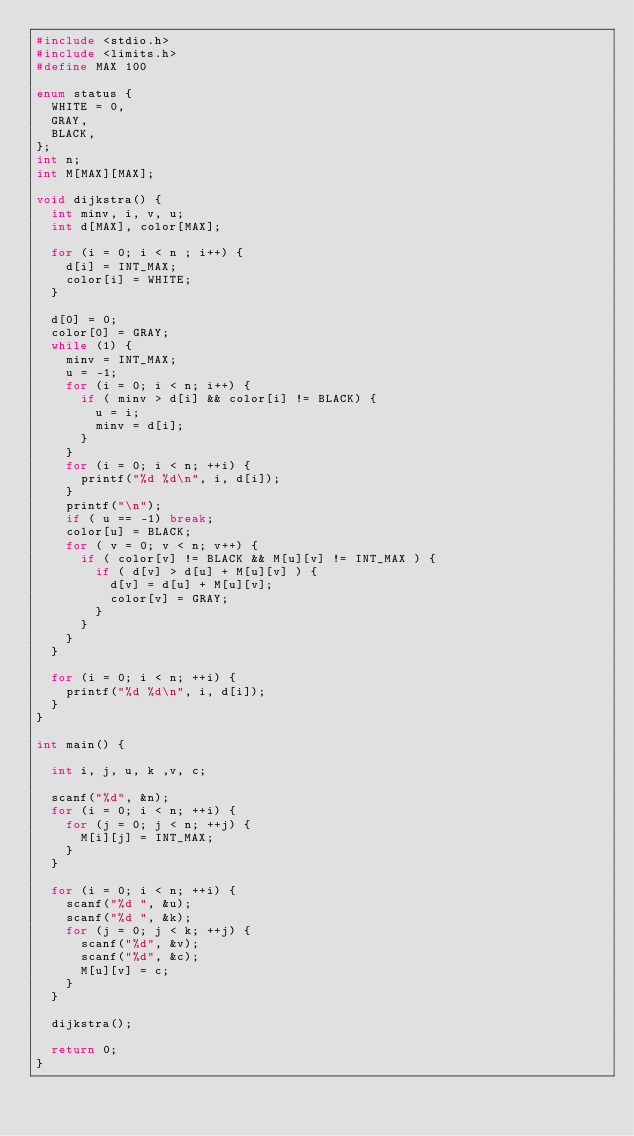<code> <loc_0><loc_0><loc_500><loc_500><_C_>#include <stdio.h>
#include <limits.h>
#define MAX 100

enum status {
	WHITE = 0,
	GRAY,
	BLACK,
};
int n;
int M[MAX][MAX];

void dijkstra() {
	int minv, i, v, u;
	int d[MAX], color[MAX];
	
	for (i = 0; i < n ; i++) {
		d[i] = INT_MAX;
		color[i] = WHITE;
	}

	d[0] = 0;
	color[0] = GRAY;
	while (1) {
		minv = INT_MAX;
		u = -1;
		for (i = 0; i < n; i++) {
			if ( minv > d[i] && color[i] != BLACK) {
				u = i;
				minv = d[i];
			}
		}
		for (i = 0; i < n; ++i) {
			printf("%d %d\n", i, d[i]);
		}
		printf("\n");
		if ( u == -1) break;
		color[u] = BLACK;
		for ( v = 0; v < n; v++) {
			if ( color[v] != BLACK && M[u][v] != INT_MAX ) {
				if ( d[v] > d[u] + M[u][v] ) {
					d[v] = d[u] + M[u][v];
					color[v] = GRAY;
				}
			}
		}					   
	}

	for (i = 0; i < n; ++i) {
		printf("%d %d\n", i, d[i]);
	}
}

int main() {

	int i, j, u, k ,v, c;
	
	scanf("%d", &n);
	for (i = 0; i < n; ++i) {
		for (j = 0; j < n; ++j) {
			M[i][j] = INT_MAX;
		}
	}

	for (i = 0; i < n; ++i) {
		scanf("%d ", &u);
		scanf("%d ", &k);
		for (j = 0; j < k; ++j) {
			scanf("%d", &v);
			scanf("%d", &c);
			M[u][v] = c;
		}
	}

	dijkstra();
	
	return 0;
}</code> 